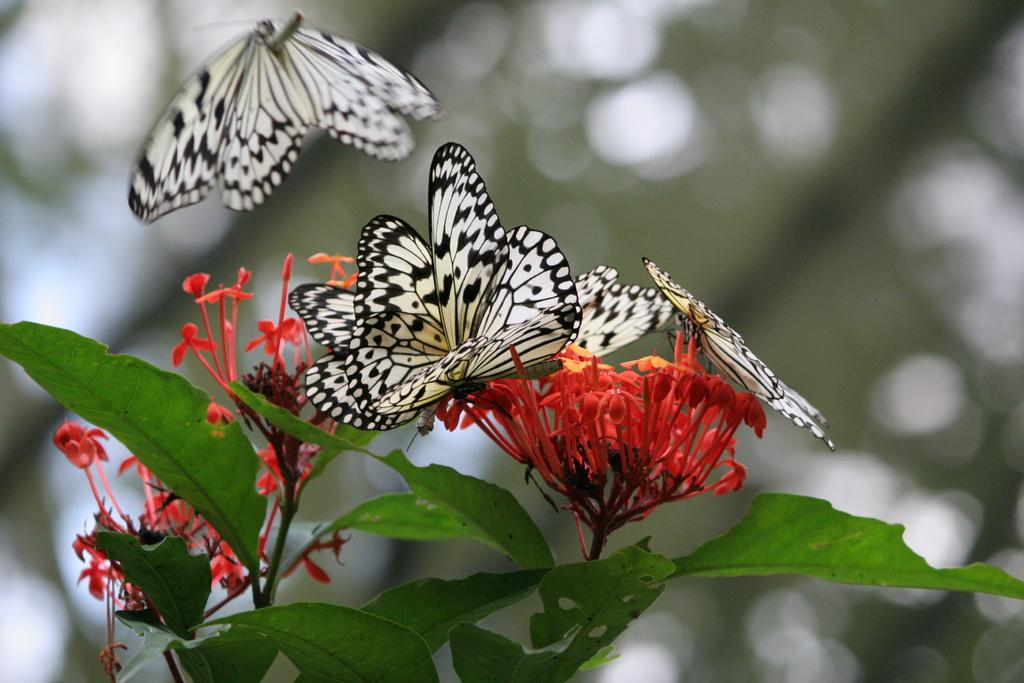What is happening on the flower in the image? There are butterflies on a flower in the image. What else is flying in the image besides the butterflies? There is another flower flying in the image. What other plant elements can be seen in the image? There are leaves in the image. How would you describe the background of the image? The backdrop of the image is blurred. Can you see a snail coiled around a wave in the image? No, there is no snail or wave present in the image. 